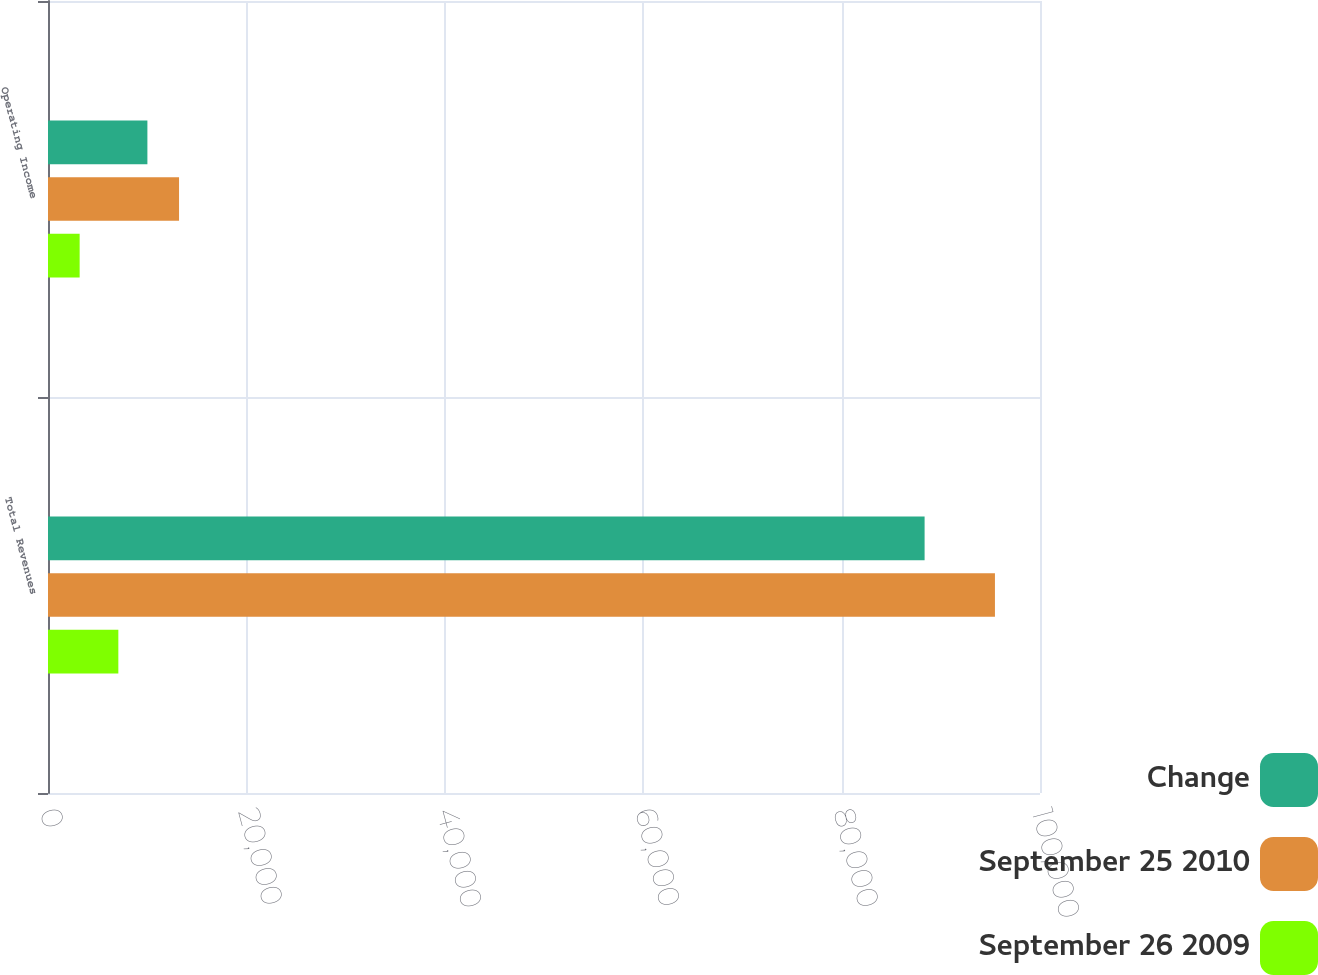<chart> <loc_0><loc_0><loc_500><loc_500><stacked_bar_chart><ecel><fcel>Total Revenues<fcel>Operating Income<nl><fcel>Change<fcel>88367<fcel>10020<nl><fcel>September 25 2010<fcel>95458<fcel>13210<nl><fcel>September 26 2009<fcel>7091<fcel>3190<nl></chart> 